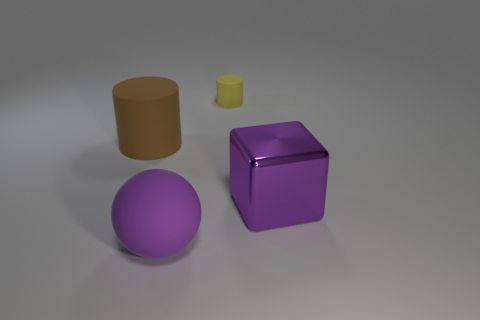Is there any other thing that is the same size as the yellow object?
Make the answer very short. No. Is there anything else that has the same material as the large cube?
Your response must be concise. No. There is a rubber cylinder that is in front of the tiny yellow rubber cylinder; what color is it?
Offer a terse response. Brown. Does the matte thing in front of the brown thing have the same size as the big brown matte cylinder?
Provide a succinct answer. Yes. Is the number of small yellow things less than the number of rubber cylinders?
Your answer should be very brief. Yes. There is a thing that is the same color as the sphere; what shape is it?
Provide a short and direct response. Cube. There is a small yellow cylinder; how many large balls are behind it?
Ensure brevity in your answer.  0. Does the large brown thing have the same shape as the small yellow thing?
Provide a short and direct response. Yes. How many things are in front of the purple metal object and behind the brown rubber thing?
Ensure brevity in your answer.  0. How many objects are small gray metallic cylinders or things behind the purple matte object?
Ensure brevity in your answer.  3. 